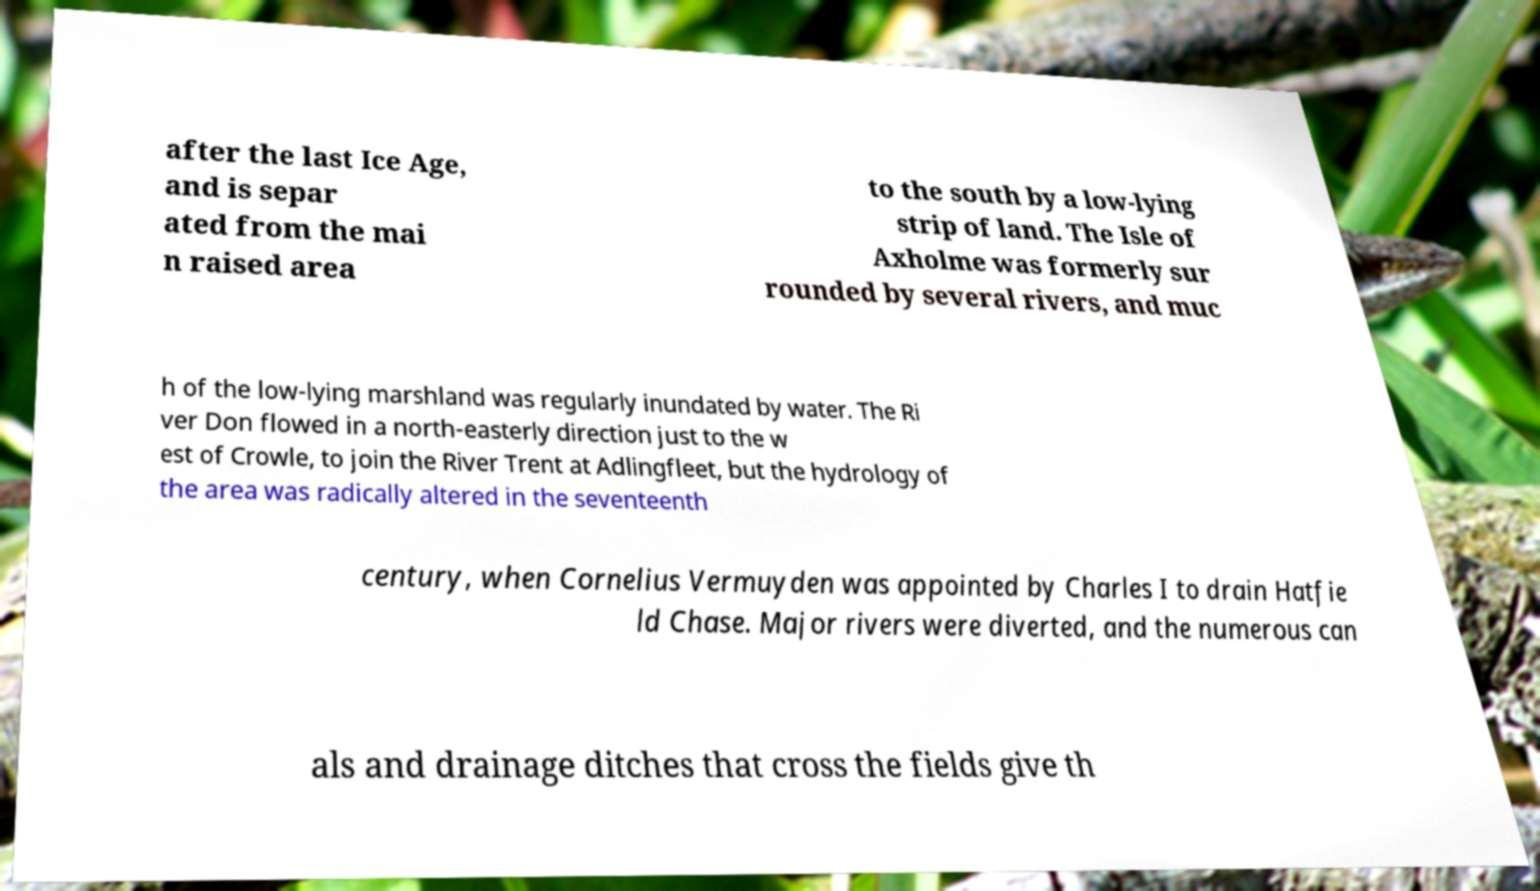Please read and relay the text visible in this image. What does it say? after the last Ice Age, and is separ ated from the mai n raised area to the south by a low-lying strip of land. The Isle of Axholme was formerly sur rounded by several rivers, and muc h of the low-lying marshland was regularly inundated by water. The Ri ver Don flowed in a north-easterly direction just to the w est of Crowle, to join the River Trent at Adlingfleet, but the hydrology of the area was radically altered in the seventeenth century, when Cornelius Vermuyden was appointed by Charles I to drain Hatfie ld Chase. Major rivers were diverted, and the numerous can als and drainage ditches that cross the fields give th 